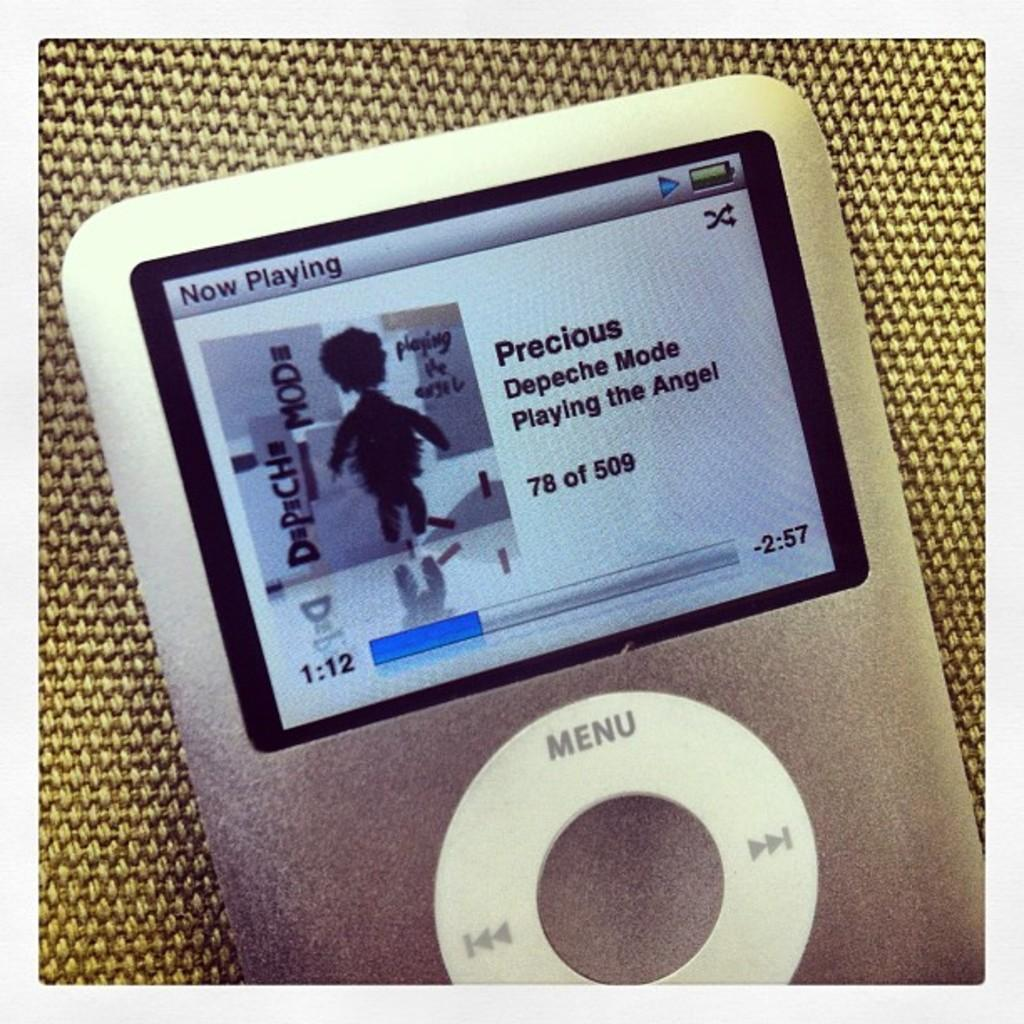What type of device is visible in the image? There is a device with a screen in the image. Can you describe the location of the device in the image? The device is placed on a surface. What color is the sweater draped over the device in the image? There is no sweater present in the image. What type of drink can be seen in a straw next to the device in the image? There is no straw or drink present in the image. 